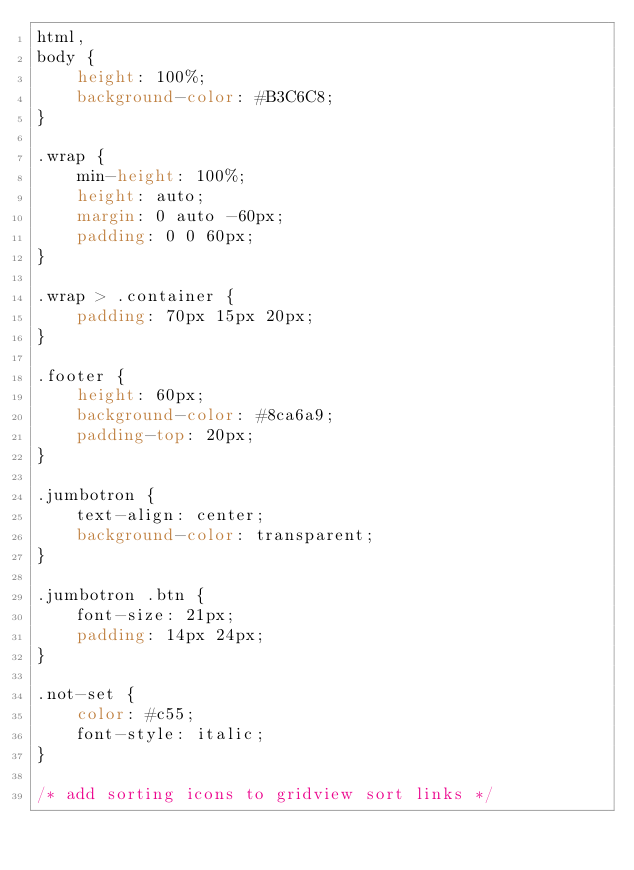Convert code to text. <code><loc_0><loc_0><loc_500><loc_500><_CSS_>html,
body {
    height: 100%;
    background-color: #B3C6C8;
}

.wrap {
    min-height: 100%;
    height: auto;
    margin: 0 auto -60px;
    padding: 0 0 60px;
}

.wrap > .container {
    padding: 70px 15px 20px;
}

.footer {
    height: 60px;
    background-color: #8ca6a9;    
    padding-top: 20px;
}

.jumbotron {
    text-align: center;
    background-color: transparent;
}

.jumbotron .btn {
    font-size: 21px;
    padding: 14px 24px;
}

.not-set {
    color: #c55;
    font-style: italic;
}

/* add sorting icons to gridview sort links */</code> 